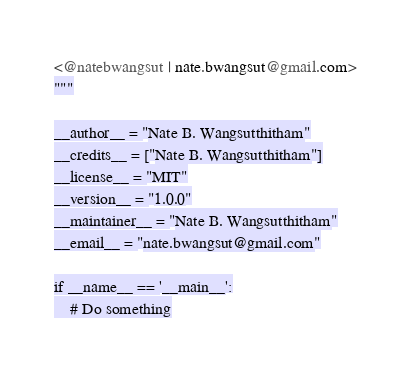<code> <loc_0><loc_0><loc_500><loc_500><_Python_><@natebwangsut | nate.bwangsut@gmail.com>
"""

__author__ = "Nate B. Wangsutthitham"
__credits__ = ["Nate B. Wangsutthitham"]
__license__ = "MIT"
__version__ = "1.0.0"
__maintainer__ = "Nate B. Wangsutthitham"
__email__ = "nate.bwangsut@gmail.com"

if __name__ == '__main__':
    # Do something
</code> 